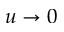Convert formula to latex. <formula><loc_0><loc_0><loc_500><loc_500>u \to 0</formula> 